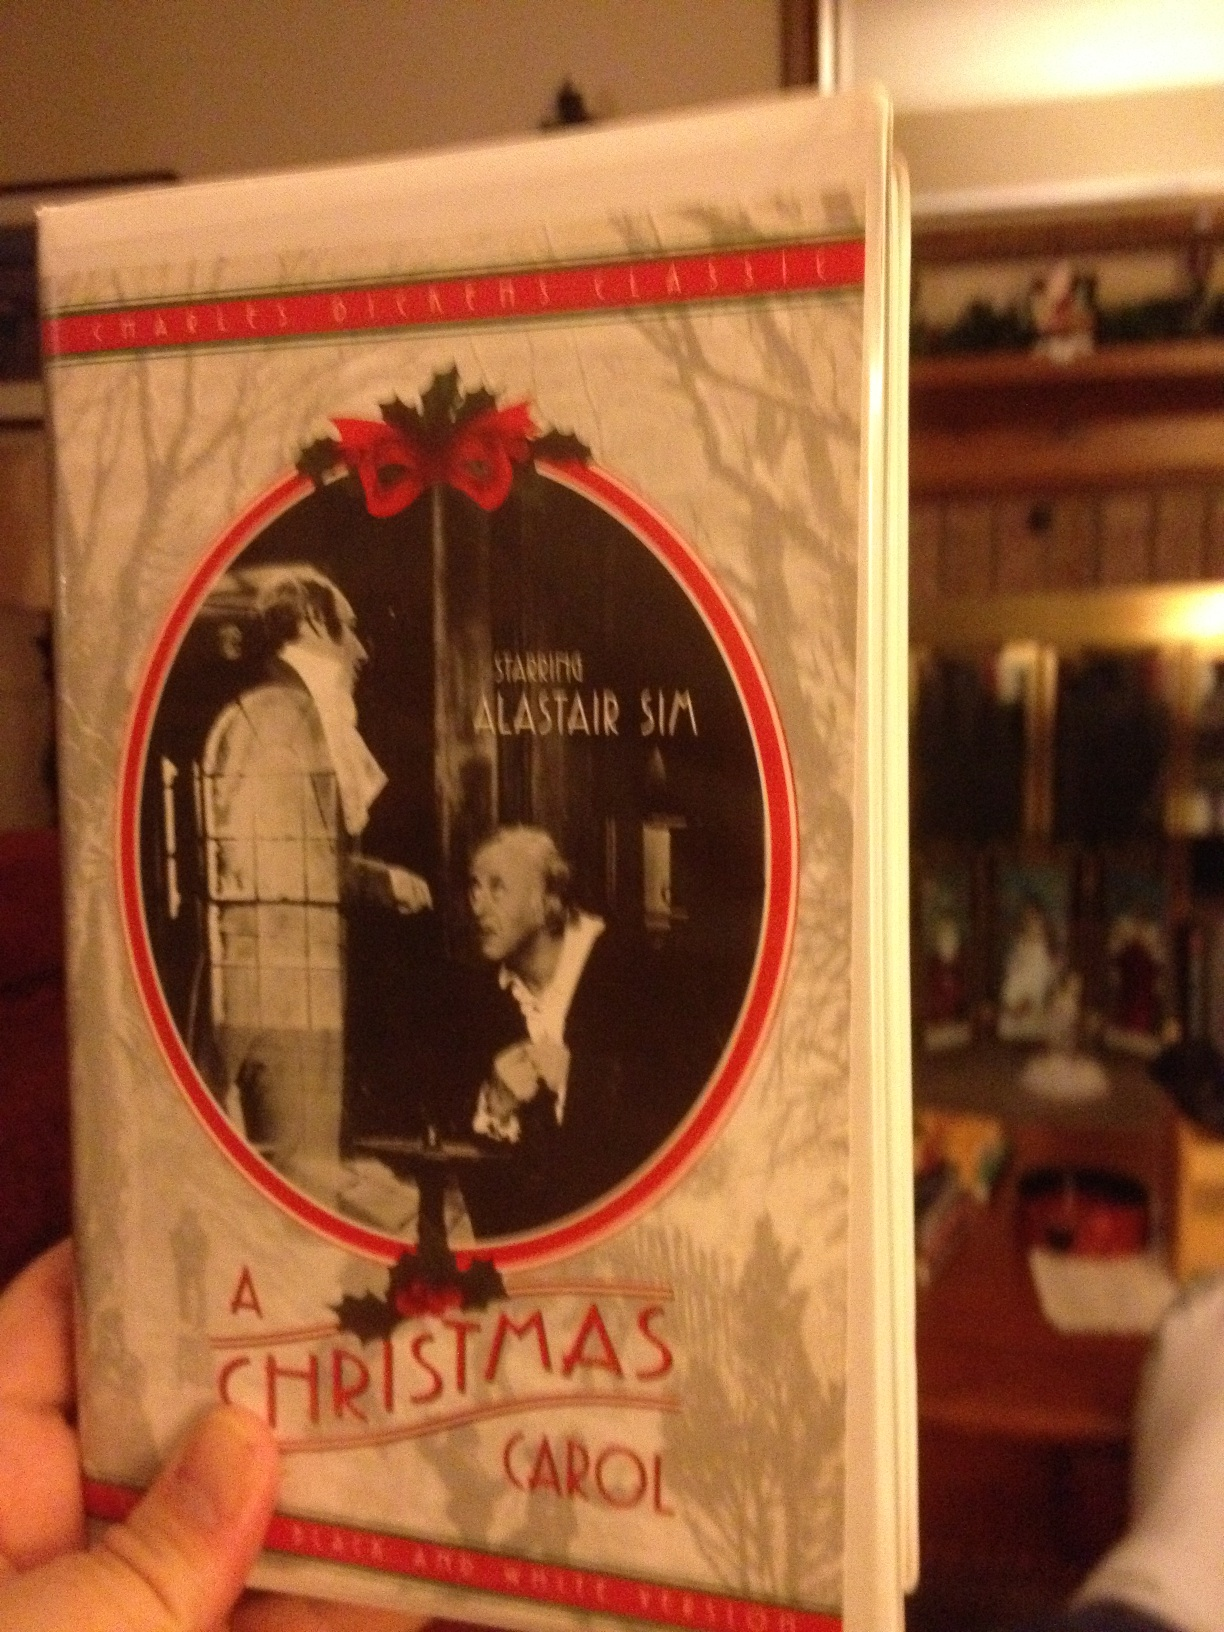Can you tell me a short version of the story? Sure! 'A Christmas Carol' follows the story of Ebenezer Scrooge, a miserly old man, who is visited by ghosts on Christmas Eve. The Ghosts of Christmas Past, Present, and Yet to Come show him his life, revealing the mistakes he's made and the lonely future that awaits him if he doesn't change. Touched by these visions, Scrooge wakes up on Christmas morning with a renewed spirit. He becomes kind, generous, and celebrates life with joy and a newfound sense of community. 